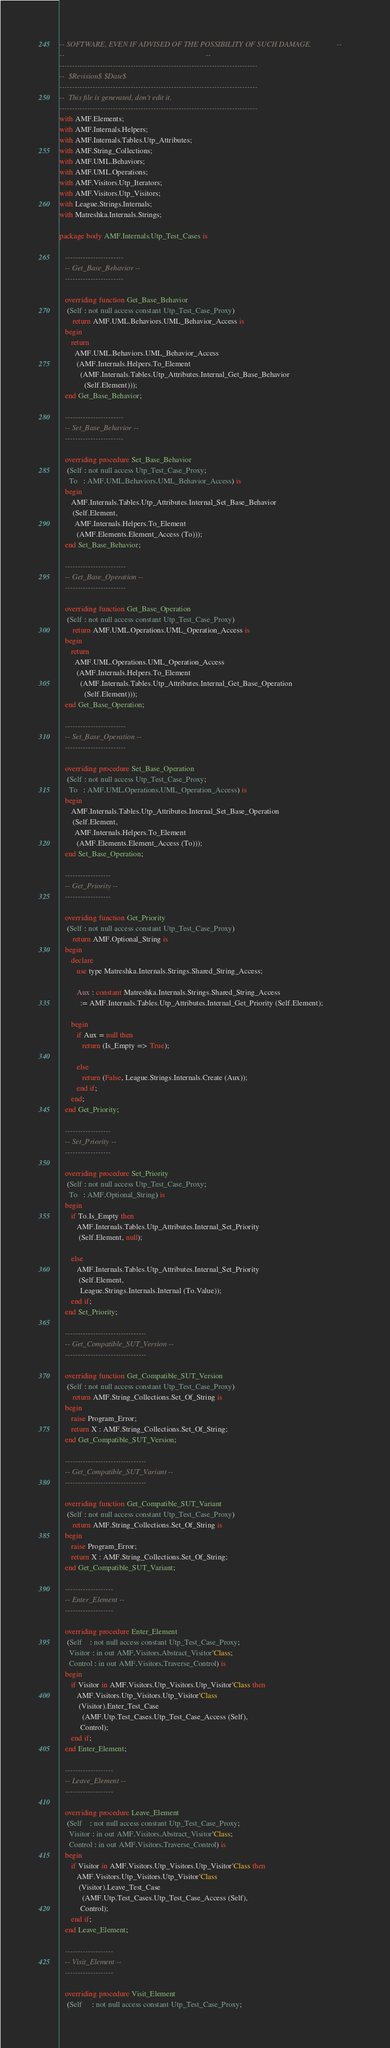Convert code to text. <code><loc_0><loc_0><loc_500><loc_500><_Ada_>-- SOFTWARE, EVEN IF ADVISED OF THE POSSIBILITY OF SUCH DAMAGE.             --
--                                                                          --
------------------------------------------------------------------------------
--  $Revision$ $Date$
------------------------------------------------------------------------------
--  This file is generated, don't edit it.
------------------------------------------------------------------------------
with AMF.Elements;
with AMF.Internals.Helpers;
with AMF.Internals.Tables.Utp_Attributes;
with AMF.String_Collections;
with AMF.UML.Behaviors;
with AMF.UML.Operations;
with AMF.Visitors.Utp_Iterators;
with AMF.Visitors.Utp_Visitors;
with League.Strings.Internals;
with Matreshka.Internals.Strings;

package body AMF.Internals.Utp_Test_Cases is

   -----------------------
   -- Get_Base_Behavior --
   -----------------------

   overriding function Get_Base_Behavior
    (Self : not null access constant Utp_Test_Case_Proxy)
       return AMF.UML.Behaviors.UML_Behavior_Access is
   begin
      return
        AMF.UML.Behaviors.UML_Behavior_Access
         (AMF.Internals.Helpers.To_Element
           (AMF.Internals.Tables.Utp_Attributes.Internal_Get_Base_Behavior
             (Self.Element)));
   end Get_Base_Behavior;

   -----------------------
   -- Set_Base_Behavior --
   -----------------------

   overriding procedure Set_Base_Behavior
    (Self : not null access Utp_Test_Case_Proxy;
     To   : AMF.UML.Behaviors.UML_Behavior_Access) is
   begin
      AMF.Internals.Tables.Utp_Attributes.Internal_Set_Base_Behavior
       (Self.Element,
        AMF.Internals.Helpers.To_Element
         (AMF.Elements.Element_Access (To)));
   end Set_Base_Behavior;

   ------------------------
   -- Get_Base_Operation --
   ------------------------

   overriding function Get_Base_Operation
    (Self : not null access constant Utp_Test_Case_Proxy)
       return AMF.UML.Operations.UML_Operation_Access is
   begin
      return
        AMF.UML.Operations.UML_Operation_Access
         (AMF.Internals.Helpers.To_Element
           (AMF.Internals.Tables.Utp_Attributes.Internal_Get_Base_Operation
             (Self.Element)));
   end Get_Base_Operation;

   ------------------------
   -- Set_Base_Operation --
   ------------------------

   overriding procedure Set_Base_Operation
    (Self : not null access Utp_Test_Case_Proxy;
     To   : AMF.UML.Operations.UML_Operation_Access) is
   begin
      AMF.Internals.Tables.Utp_Attributes.Internal_Set_Base_Operation
       (Self.Element,
        AMF.Internals.Helpers.To_Element
         (AMF.Elements.Element_Access (To)));
   end Set_Base_Operation;

   ------------------
   -- Get_Priority --
   ------------------

   overriding function Get_Priority
    (Self : not null access constant Utp_Test_Case_Proxy)
       return AMF.Optional_String is
   begin
      declare
         use type Matreshka.Internals.Strings.Shared_String_Access;

         Aux : constant Matreshka.Internals.Strings.Shared_String_Access
           := AMF.Internals.Tables.Utp_Attributes.Internal_Get_Priority (Self.Element);

      begin
         if Aux = null then
            return (Is_Empty => True);

         else
            return (False, League.Strings.Internals.Create (Aux));
         end if;
      end;
   end Get_Priority;

   ------------------
   -- Set_Priority --
   ------------------

   overriding procedure Set_Priority
    (Self : not null access Utp_Test_Case_Proxy;
     To   : AMF.Optional_String) is
   begin
      if To.Is_Empty then
         AMF.Internals.Tables.Utp_Attributes.Internal_Set_Priority
          (Self.Element, null);

      else
         AMF.Internals.Tables.Utp_Attributes.Internal_Set_Priority
          (Self.Element,
           League.Strings.Internals.Internal (To.Value));
      end if;
   end Set_Priority;

   --------------------------------
   -- Get_Compatible_SUT_Version --
   --------------------------------

   overriding function Get_Compatible_SUT_Version
    (Self : not null access constant Utp_Test_Case_Proxy)
       return AMF.String_Collections.Set_Of_String is
   begin
      raise Program_Error;
      return X : AMF.String_Collections.Set_Of_String;
   end Get_Compatible_SUT_Version;

   --------------------------------
   -- Get_Compatible_SUT_Variant --
   --------------------------------

   overriding function Get_Compatible_SUT_Variant
    (Self : not null access constant Utp_Test_Case_Proxy)
       return AMF.String_Collections.Set_Of_String is
   begin
      raise Program_Error;
      return X : AMF.String_Collections.Set_Of_String;
   end Get_Compatible_SUT_Variant;

   -------------------
   -- Enter_Element --
   -------------------

   overriding procedure Enter_Element
    (Self    : not null access constant Utp_Test_Case_Proxy;
     Visitor : in out AMF.Visitors.Abstract_Visitor'Class;
     Control : in out AMF.Visitors.Traverse_Control) is
   begin
      if Visitor in AMF.Visitors.Utp_Visitors.Utp_Visitor'Class then
         AMF.Visitors.Utp_Visitors.Utp_Visitor'Class
          (Visitor).Enter_Test_Case
            (AMF.Utp.Test_Cases.Utp_Test_Case_Access (Self),
           Control);
      end if;
   end Enter_Element;

   -------------------
   -- Leave_Element --
   -------------------

   overriding procedure Leave_Element
    (Self    : not null access constant Utp_Test_Case_Proxy;
     Visitor : in out AMF.Visitors.Abstract_Visitor'Class;
     Control : in out AMF.Visitors.Traverse_Control) is
   begin
      if Visitor in AMF.Visitors.Utp_Visitors.Utp_Visitor'Class then
         AMF.Visitors.Utp_Visitors.Utp_Visitor'Class
          (Visitor).Leave_Test_Case
            (AMF.Utp.Test_Cases.Utp_Test_Case_Access (Self),
           Control);
      end if;
   end Leave_Element;

   -------------------
   -- Visit_Element --
   -------------------

   overriding procedure Visit_Element
    (Self     : not null access constant Utp_Test_Case_Proxy;</code> 